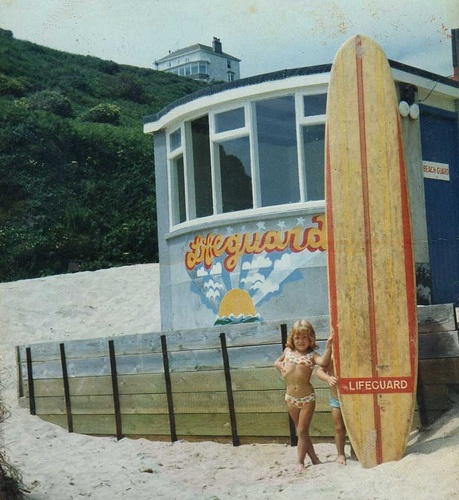Describe the objects in this image and their specific colors. I can see surfboard in lightgray, tan, gray, and brown tones, people in lightgray, maroon, gray, tan, and darkgray tones, and people in lightgray, maroon, gray, and tan tones in this image. 